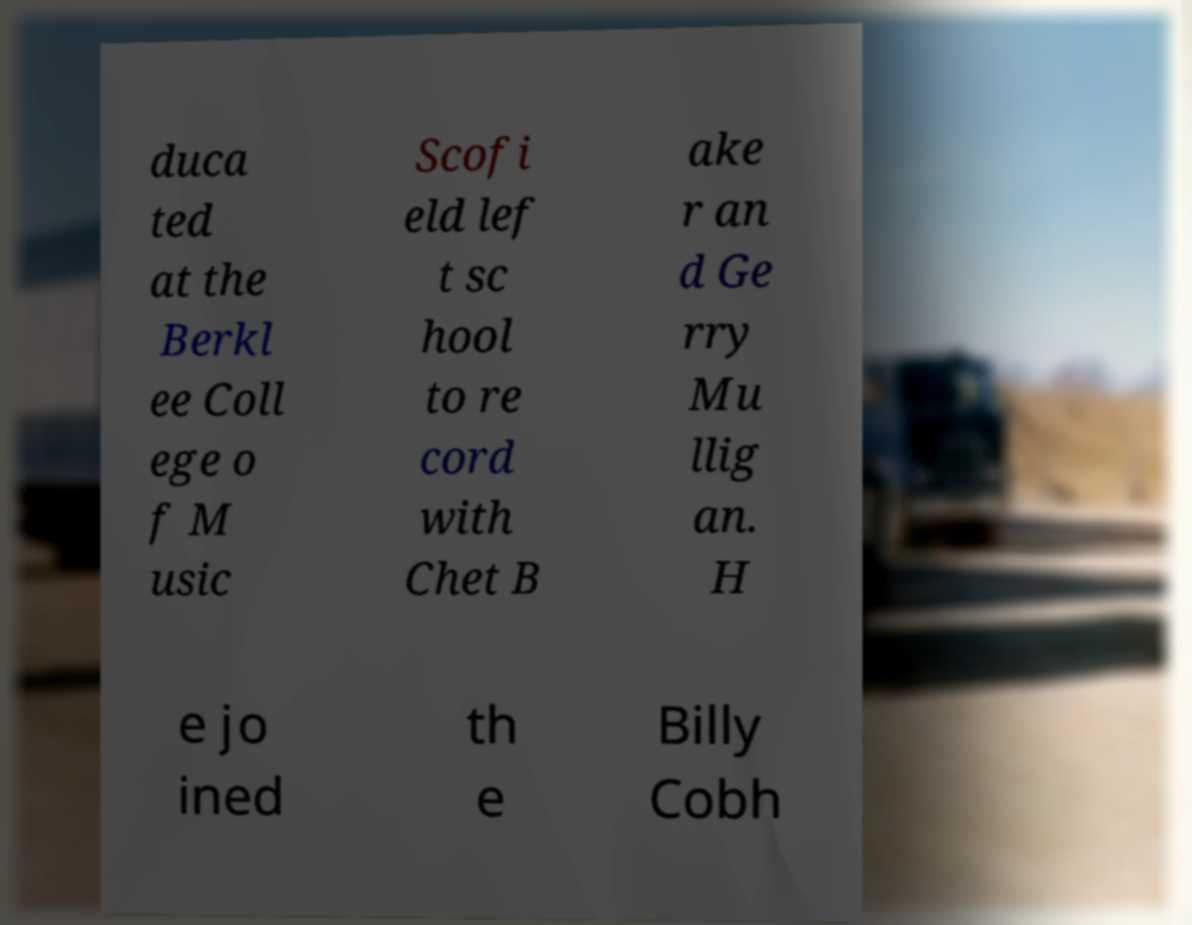Can you accurately transcribe the text from the provided image for me? duca ted at the Berkl ee Coll ege o f M usic Scofi eld lef t sc hool to re cord with Chet B ake r an d Ge rry Mu llig an. H e jo ined th e Billy Cobh 